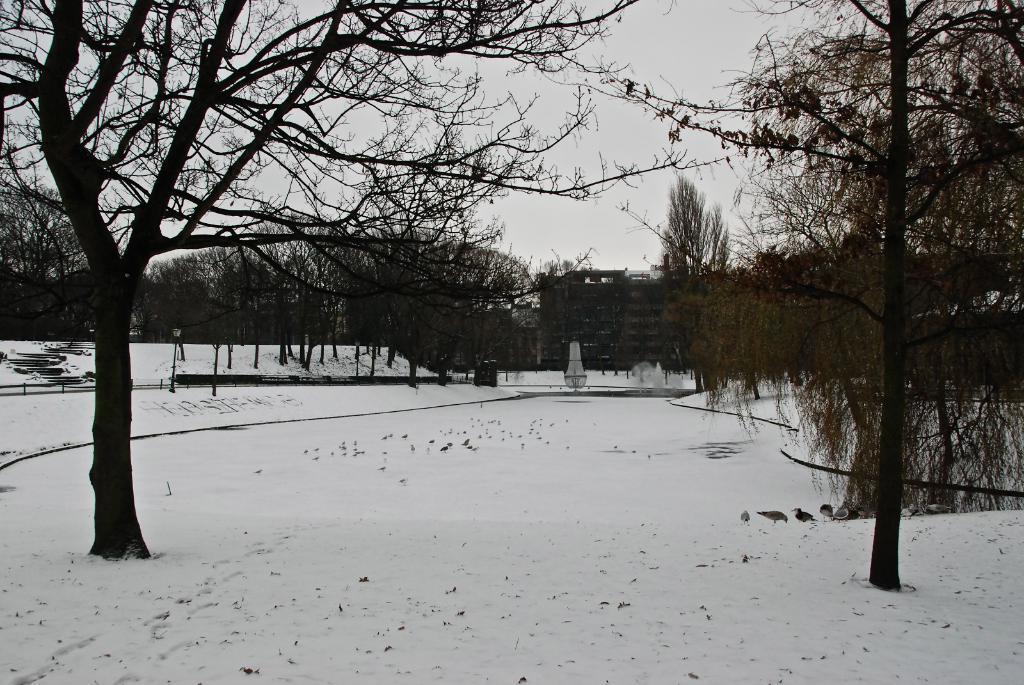How would you summarize this image in a sentence or two? In this picture we can see birds on snow, trees, building and in the background we can see the sky. 